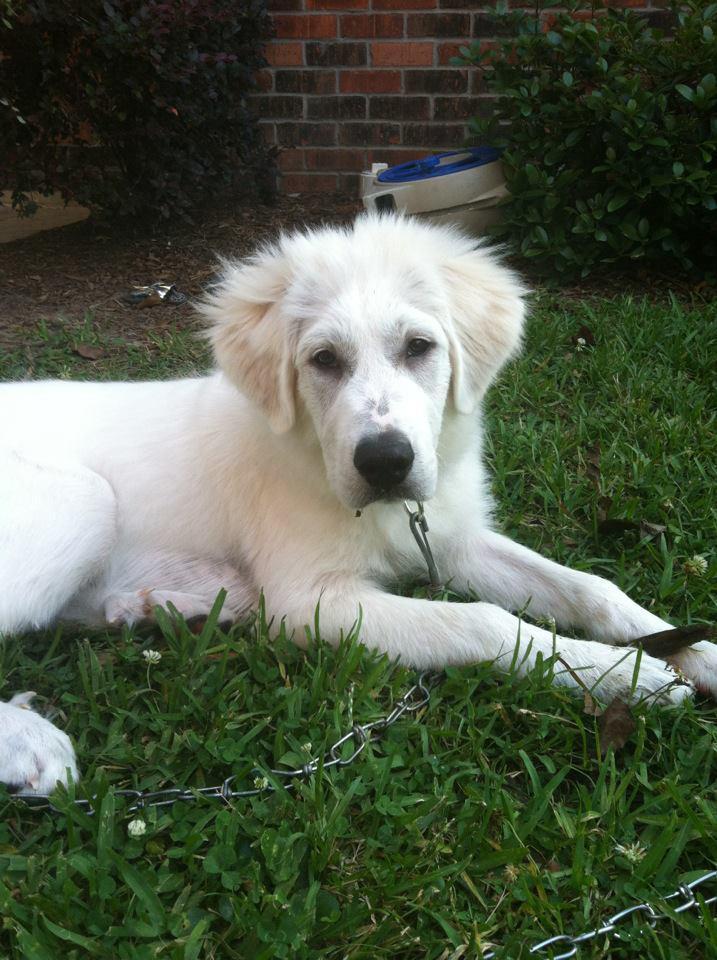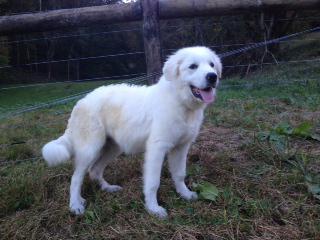The first image is the image on the left, the second image is the image on the right. Analyze the images presented: Is the assertion "The dog in the image on the left is lying on the grass." valid? Answer yes or no. Yes. The first image is the image on the left, the second image is the image on the right. Analyze the images presented: Is the assertion "An image shows one white dog reclining on the grass with its front paws extended." valid? Answer yes or no. Yes. 